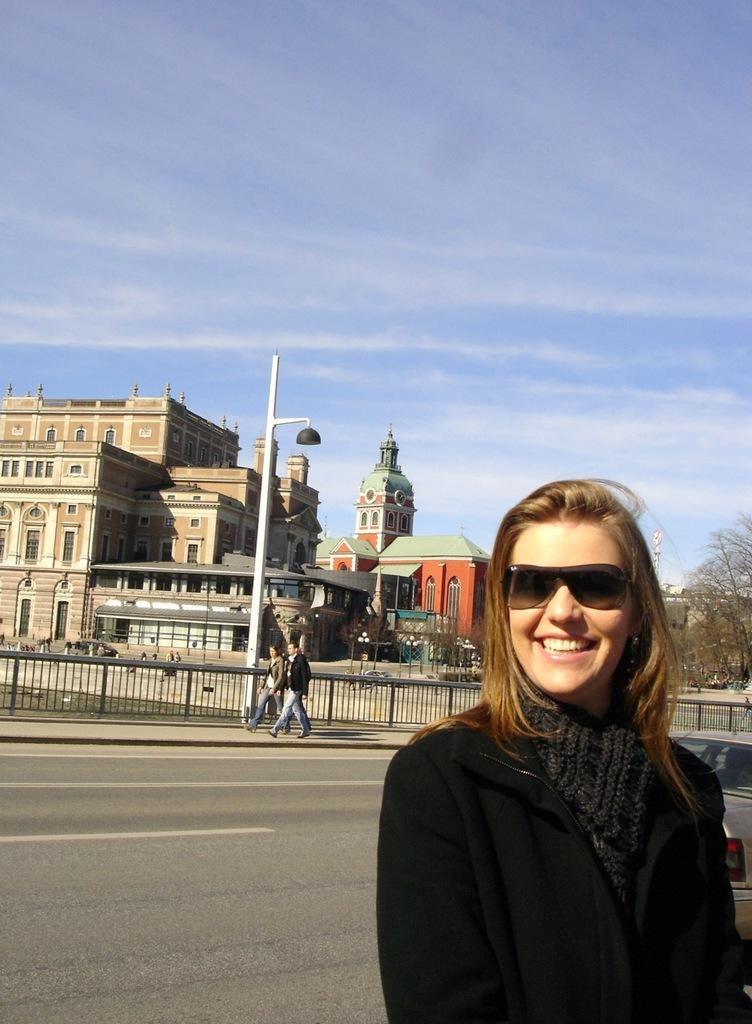Who is present in the image? There is a woman and two other persons in the image. What is the woman doing in the image? The woman is smiling in the image. What is the woman wearing on her face? The woman has goggles in the image. What can be seen in the background of the image? There are buildings, trees, and the sky visible in the background of the image. What type of rod can be seen being used for humor in the image? There is no rod or humor present in the image. Can you tell me how many times the woman kicks the pole in the image? There is no kicking or pole interaction depicted in the image. 